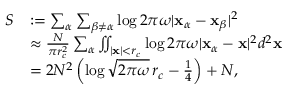Convert formula to latex. <formula><loc_0><loc_0><loc_500><loc_500>\begin{array} { r l } { S } & { \colon = \sum _ { \alpha } \sum _ { \beta \neq \alpha } \log 2 \pi \omega | \mathbf x _ { \alpha } - \mathbf x _ { \beta } | ^ { 2 } } \\ & { \approx \frac { N } { \pi r _ { c } ^ { 2 } } \sum _ { \alpha } \iint _ { | \mathbf x | < r _ { c } } \log 2 \pi \omega | \mathbf x _ { \alpha } - \mathbf x | ^ { 2 } d ^ { 2 } \mathbf x } \\ & { = 2 N ^ { 2 } \left ( \log \sqrt { 2 \pi \omega } \, r _ { c } - \frac { 1 } { 4 } \right ) + N , } \end{array}</formula> 